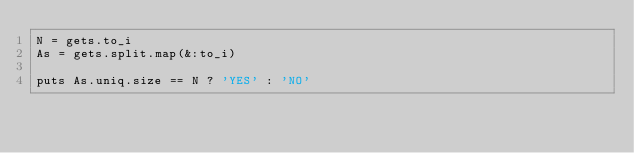<code> <loc_0><loc_0><loc_500><loc_500><_Ruby_>N = gets.to_i
As = gets.split.map(&:to_i)

puts As.uniq.size == N ? 'YES' : 'NO'</code> 